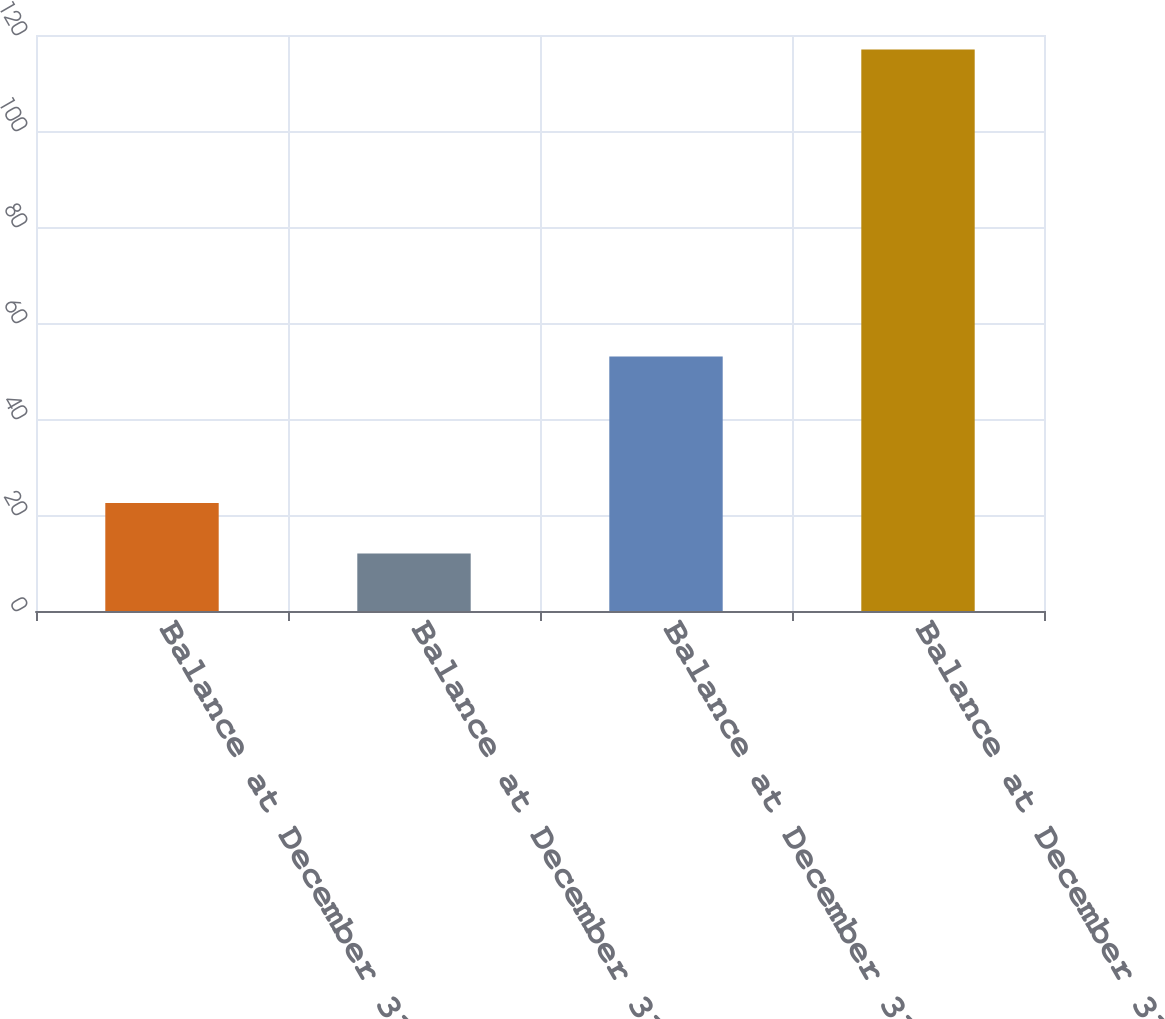Convert chart to OTSL. <chart><loc_0><loc_0><loc_500><loc_500><bar_chart><fcel>Balance at December 31 2005<fcel>Balance at December 31 2006<fcel>Balance at December 31 2007<fcel>Balance at December 31 2008<nl><fcel>22.5<fcel>12<fcel>53<fcel>117<nl></chart> 